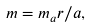<formula> <loc_0><loc_0><loc_500><loc_500>m = m _ { a } r / a ,</formula> 